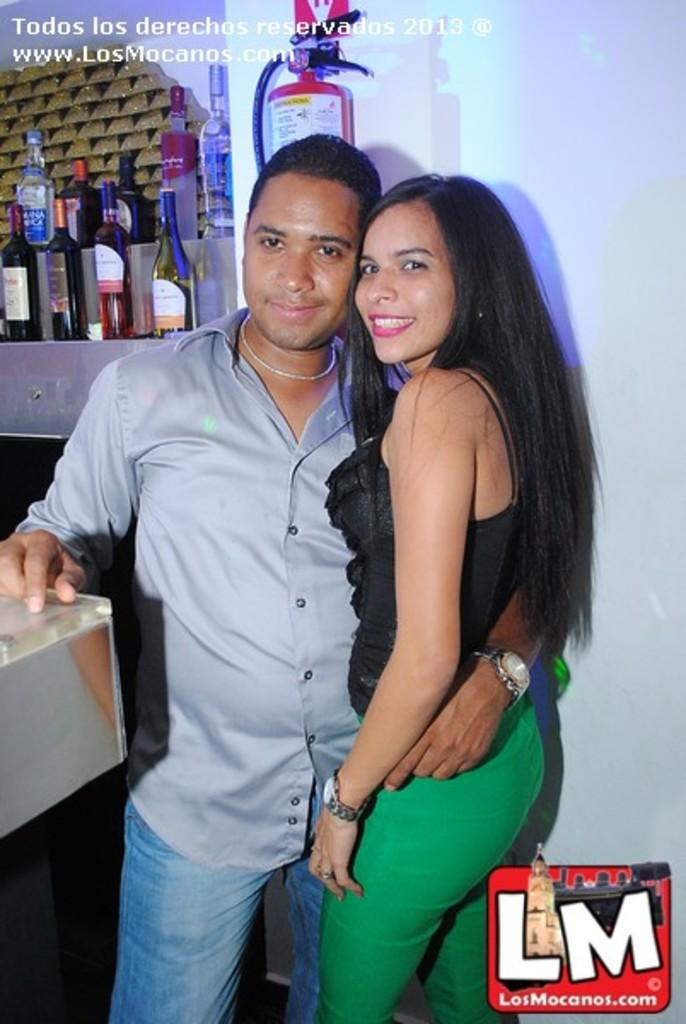How many people are in the image? There are two people in the image, a man and a woman. What are the man and woman doing in the image? The man and woman are standing together in the image. What objects can be seen in the image besides the man and woman? There are bottles and an extinguisher visible in the image. What type of structure is present in the image? There is a wall in the image. What type of music can be heard playing in the background of the image? There is no music present in the image, as it is a still photograph. How would you describe the haircut of the man in the image? The provided facts do not mention the haircut of the man, so it cannot be determined from the image. 